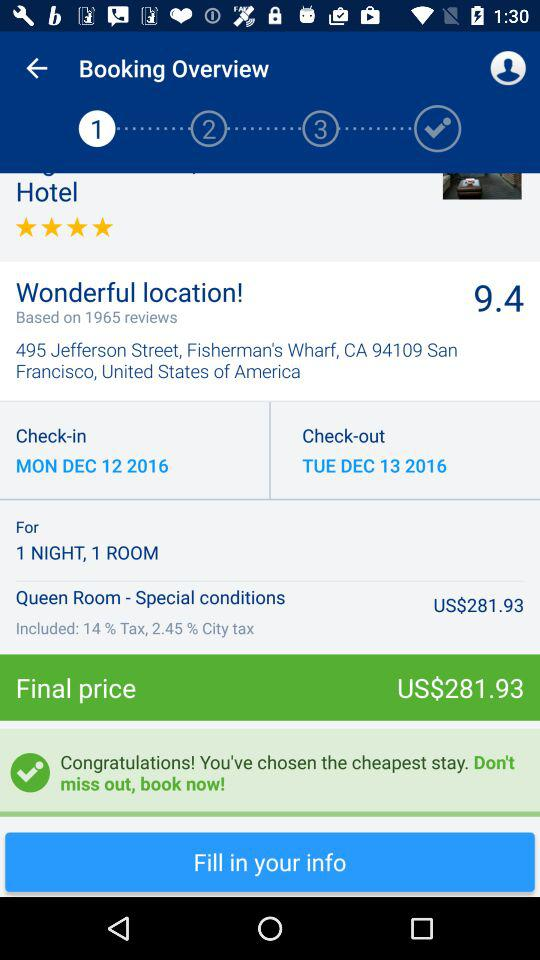How many reviews are there? There are 1965 reviews. 